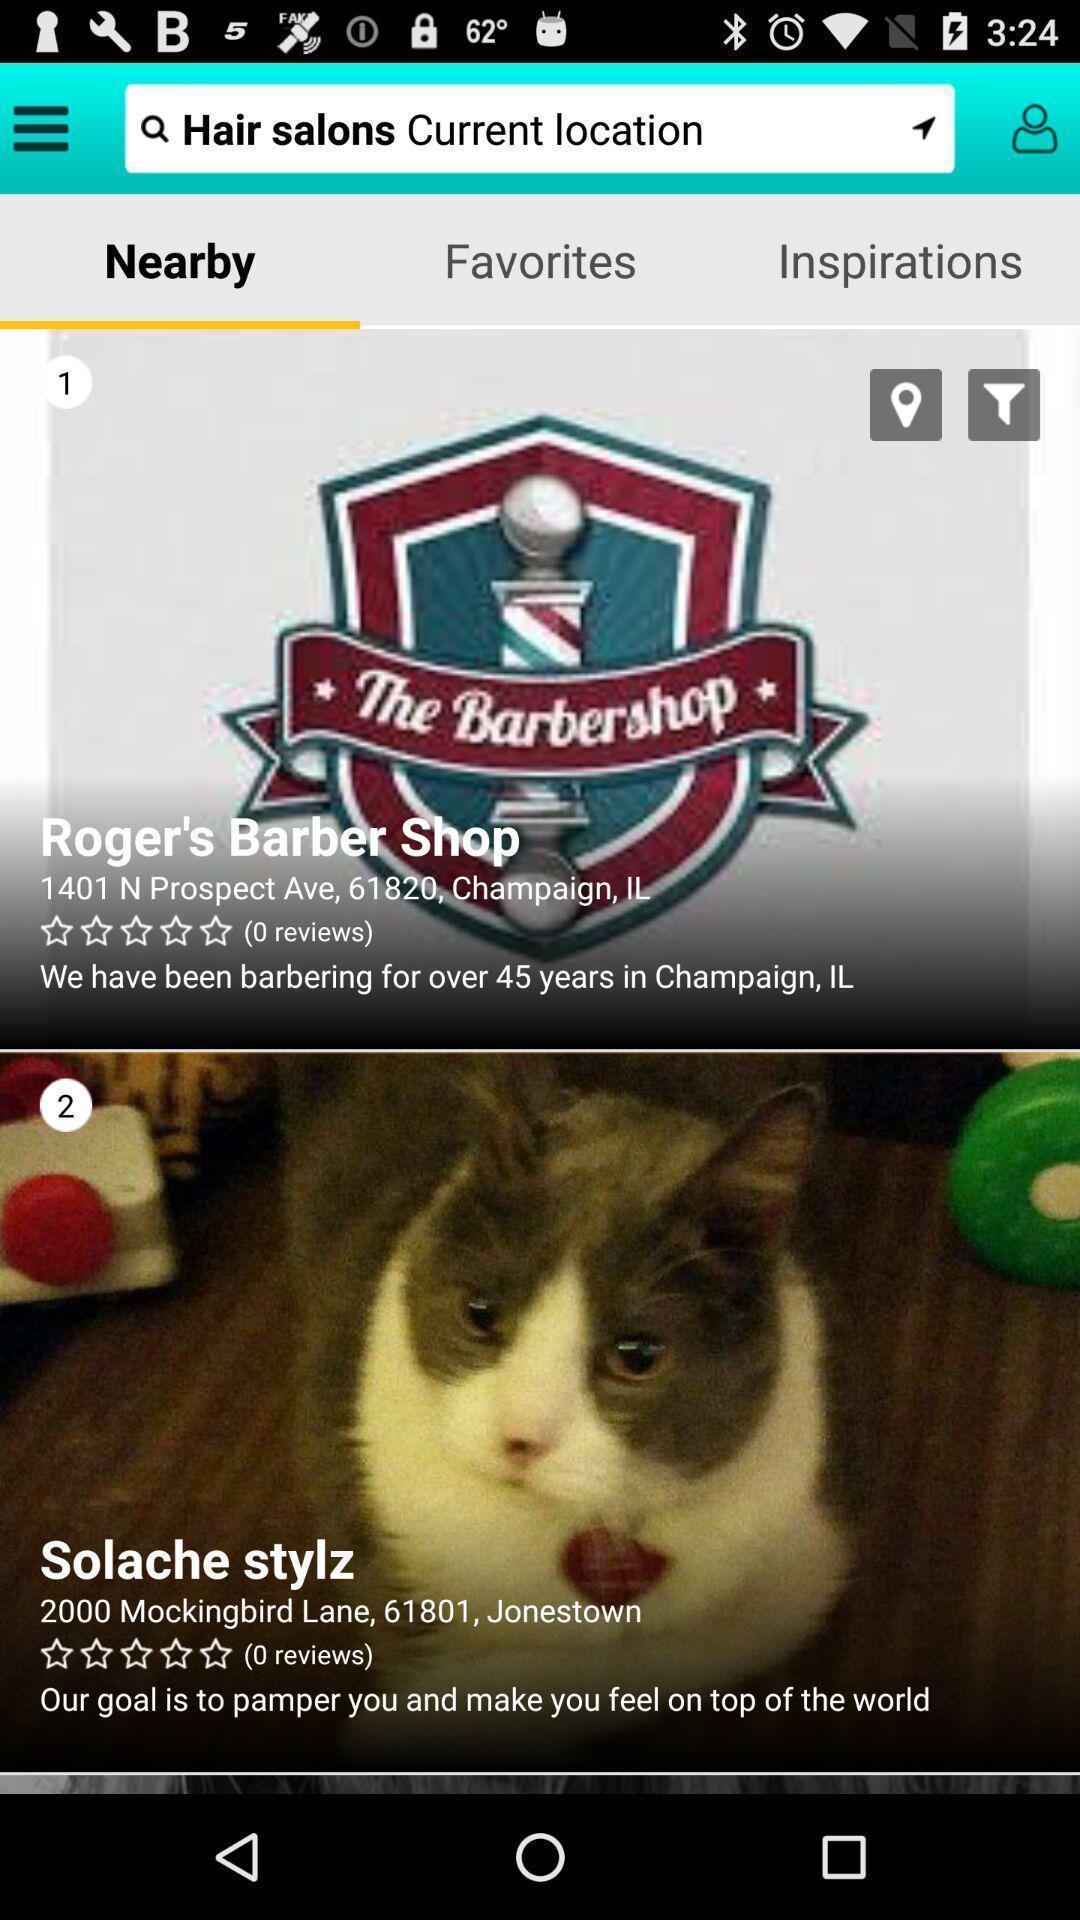Describe the key features of this screenshot. Search page of hair salons current location. 